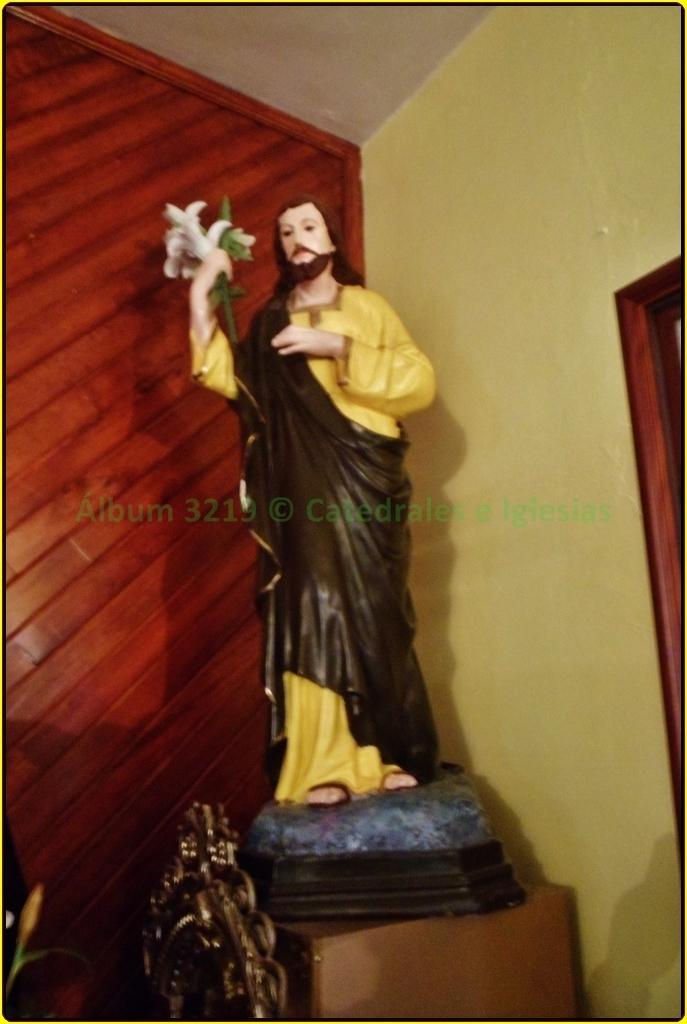What is the main subject in the center of the image? There is a statue in the center of the image. What can be seen behind the statue? There is a wall in the background of the image. What type of surface is visible in the image? There is a wooden surface in the image. What is visible at the top of the image? There is a ceiling visible at the top of the image. Can you hear the statue committing a crime in the image? There is no sound or indication of a crime in the image; it is a visual representation of a statue and its surroundings. 